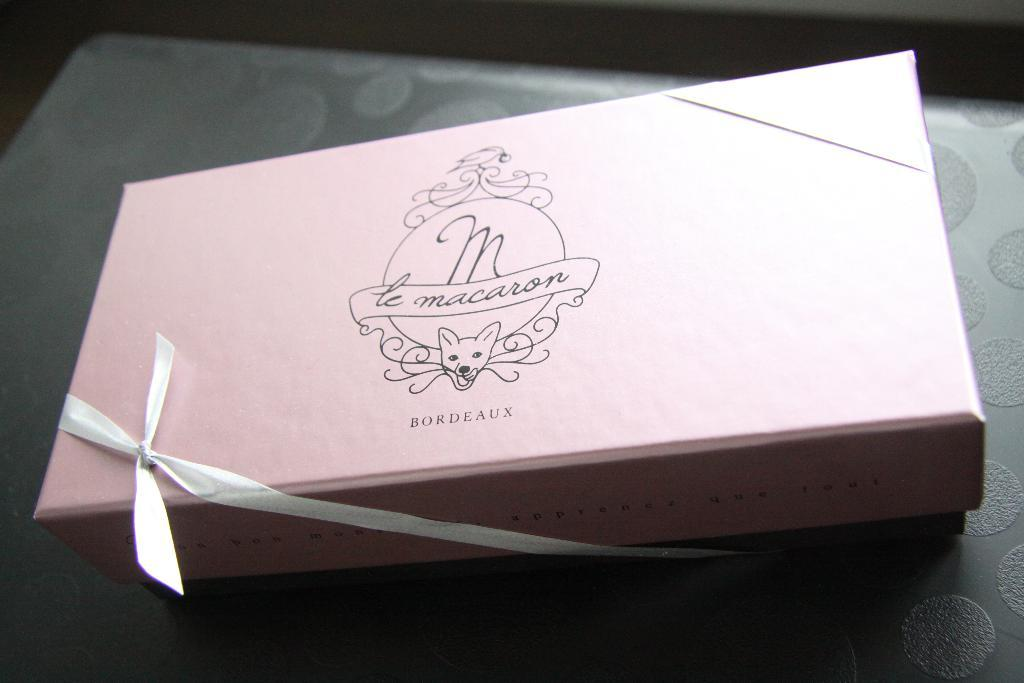<image>
Provide a brief description of the given image. the word macaron is on the box on a black surface 